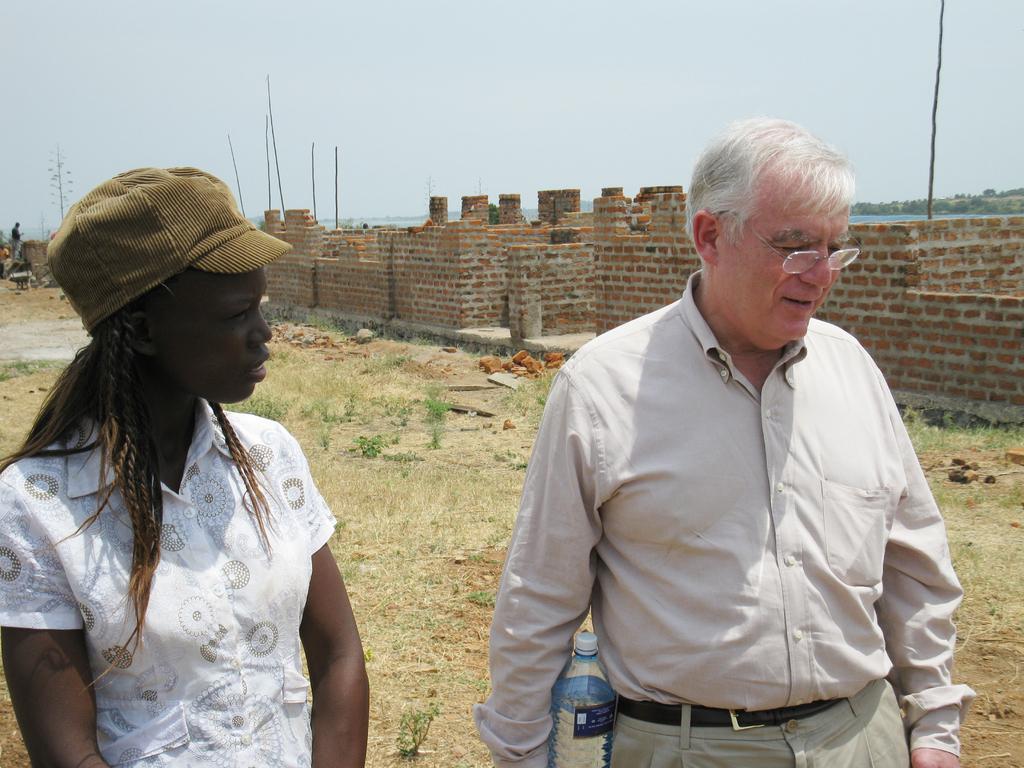Can you describe this image briefly? In this image I can see two people standing on the ground. These people are wearing the different color dresses. I can see one person with the cap. In the back I can see the brick wall and the person standing in-front of it. In the background there are many trees, poles, water and the sky. 